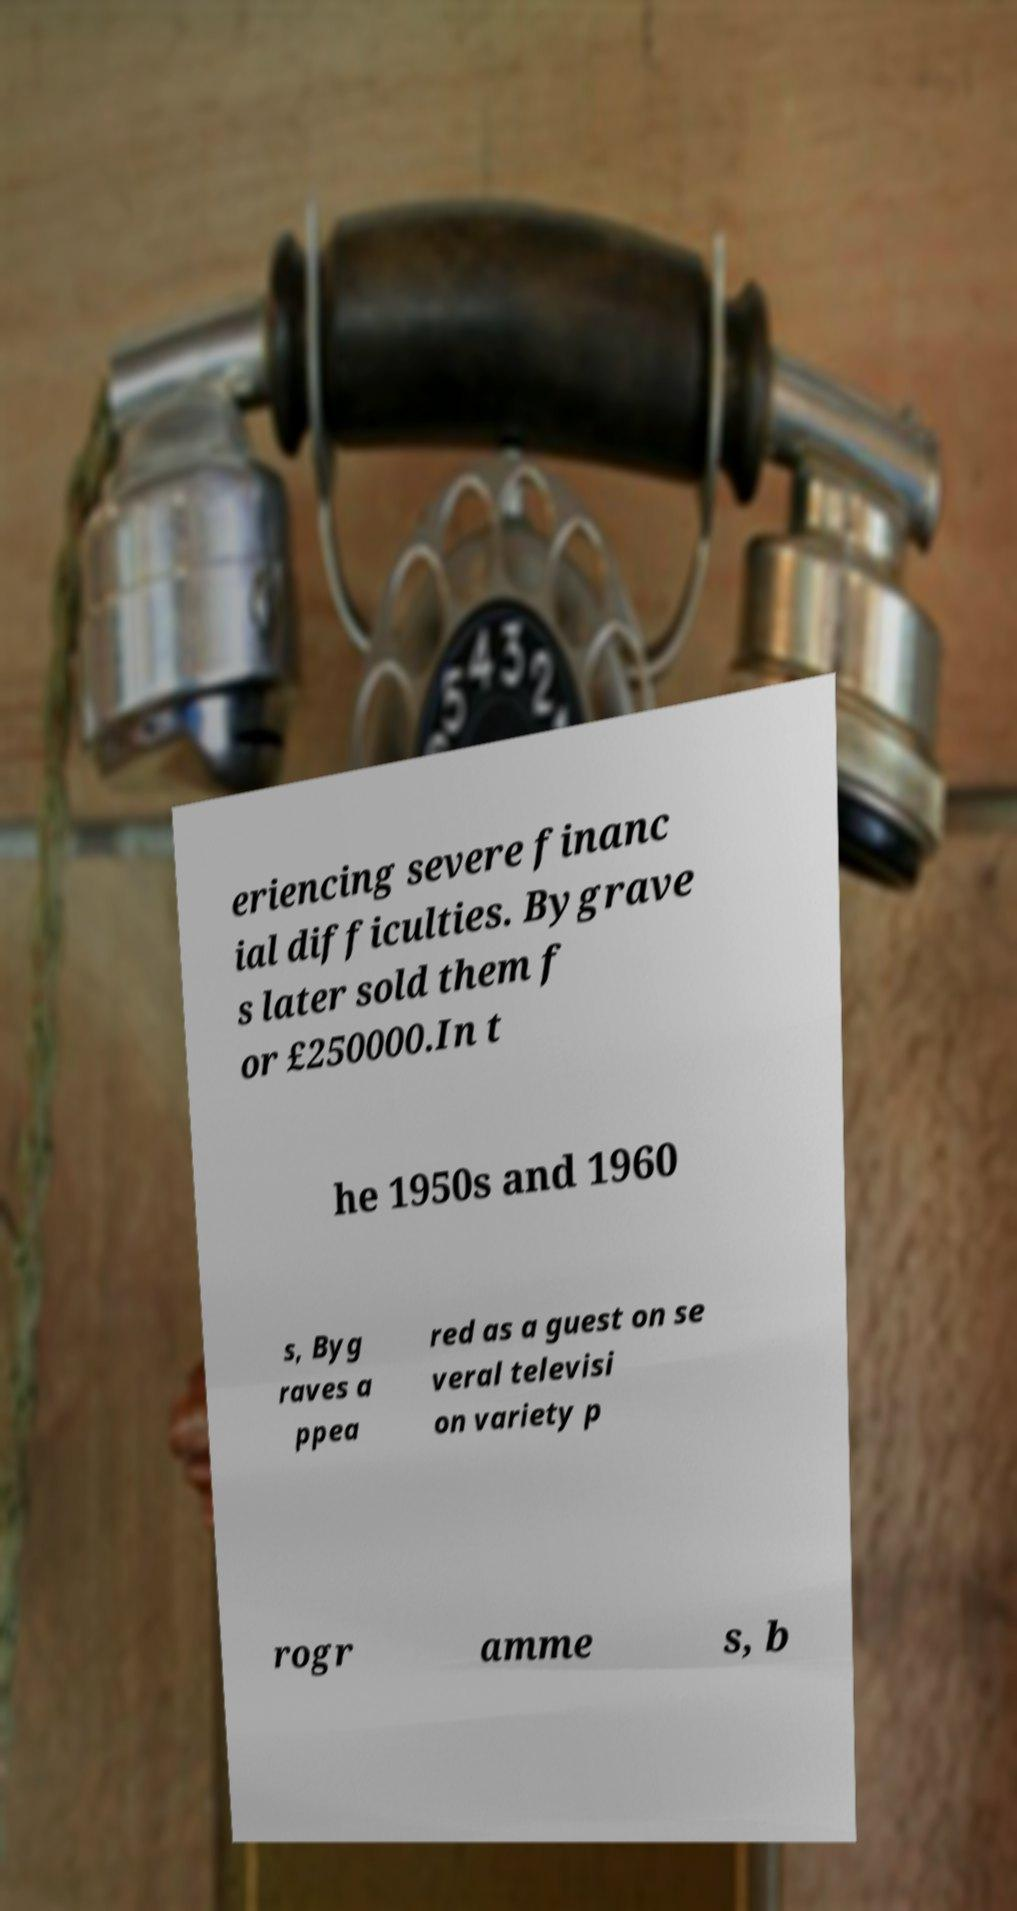I need the written content from this picture converted into text. Can you do that? eriencing severe financ ial difficulties. Bygrave s later sold them f or £250000.In t he 1950s and 1960 s, Byg raves a ppea red as a guest on se veral televisi on variety p rogr amme s, b 